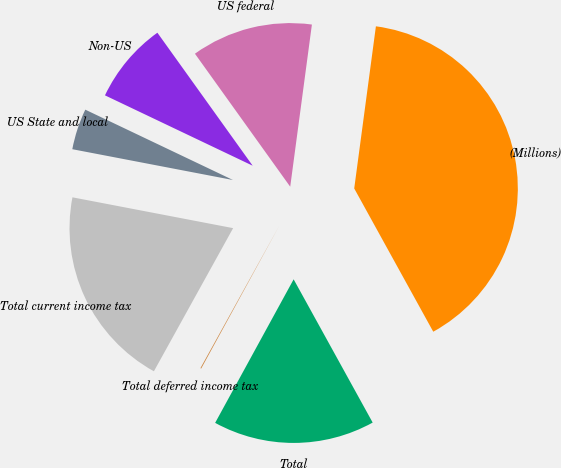Convert chart to OTSL. <chart><loc_0><loc_0><loc_500><loc_500><pie_chart><fcel>(Millions)<fcel>US federal<fcel>Non-US<fcel>US State and local<fcel>Total current income tax<fcel>Total deferred income tax<fcel>Total<nl><fcel>39.86%<fcel>12.01%<fcel>8.03%<fcel>4.06%<fcel>19.97%<fcel>0.08%<fcel>15.99%<nl></chart> 